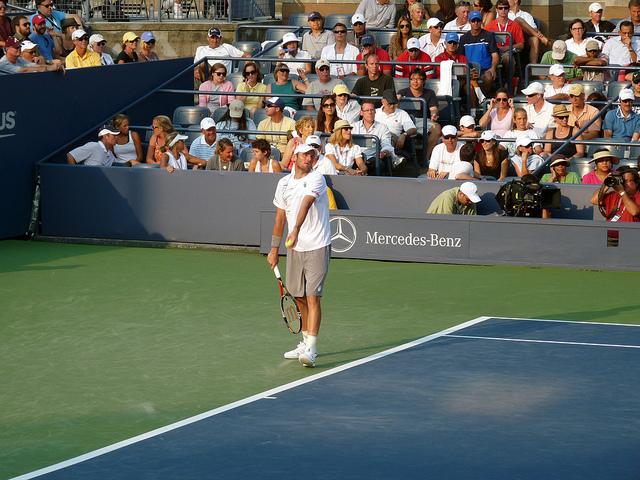What color are the man's shorts?
Write a very short answer. Gray. What percentage of the seats are empty?
Write a very short answer. 0. Who is one of the sponsors of this event?
Short answer required. Mercedes benz. What color is the tennis court?
Concise answer only. Blue. Is it a full house?
Write a very short answer. Yes. How many spectators are visible?
Concise answer only. 71. What are the spectators watching?
Answer briefly. Tennis. Has the man hit the ball yet?
Give a very brief answer. No. 